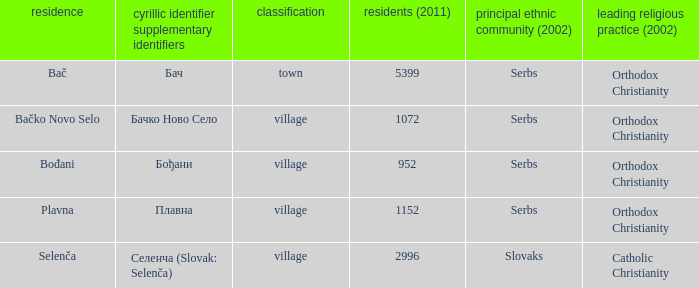What is the smallest population listed? 952.0. 